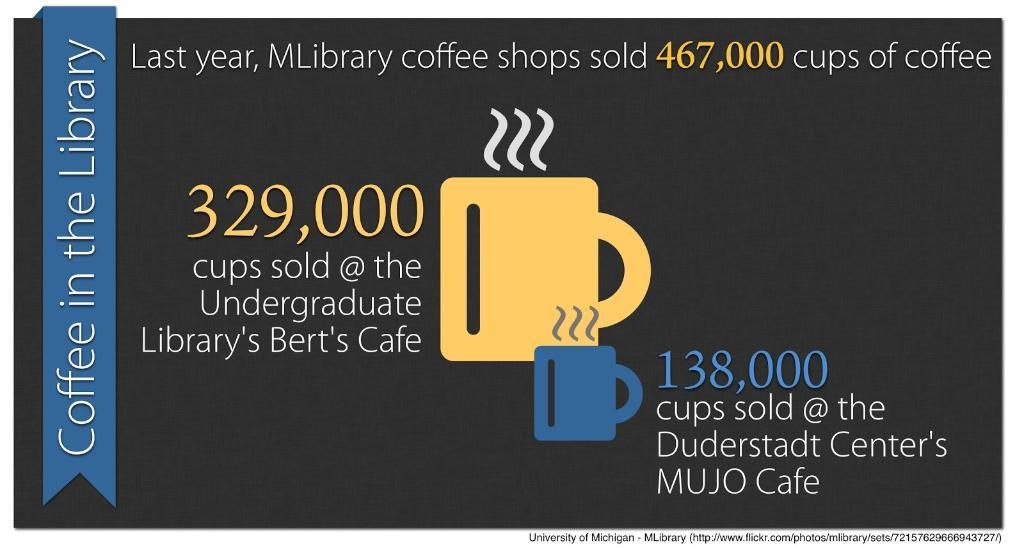<image>
Render a clear and concise summary of the photo. A certificate for a library, that says 329,000 in the center with yellow letters. 